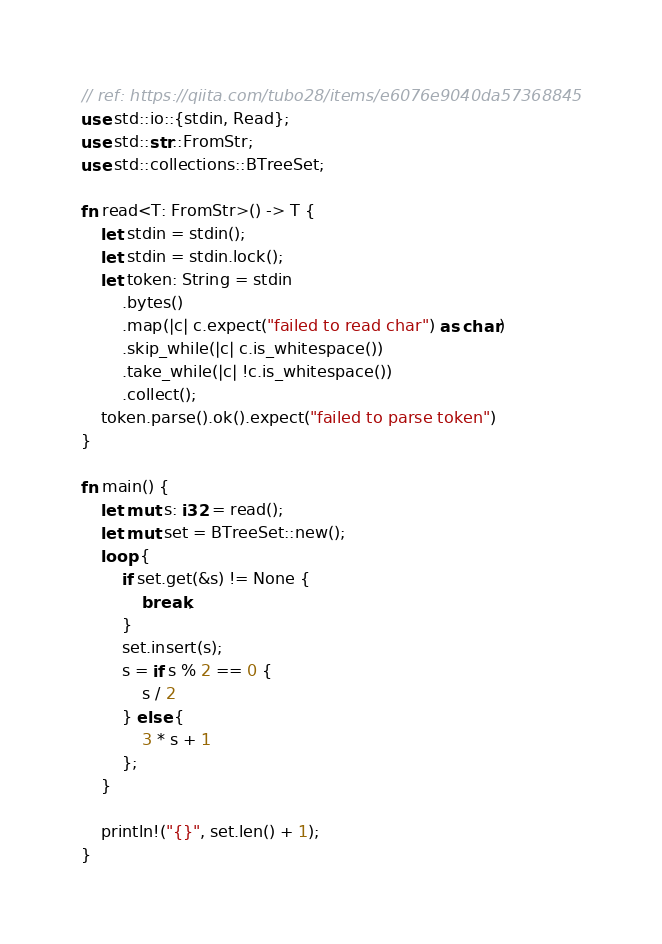Convert code to text. <code><loc_0><loc_0><loc_500><loc_500><_Rust_>// ref: https://qiita.com/tubo28/items/e6076e9040da57368845
use std::io::{stdin, Read};
use std::str::FromStr;
use std::collections::BTreeSet;

fn read<T: FromStr>() -> T {
    let stdin = stdin();
    let stdin = stdin.lock();
    let token: String = stdin
        .bytes()
        .map(|c| c.expect("failed to read char") as char)
        .skip_while(|c| c.is_whitespace())
        .take_while(|c| !c.is_whitespace())
        .collect();
    token.parse().ok().expect("failed to parse token")
}

fn main() {
    let mut s: i32 = read();
    let mut set = BTreeSet::new();
    loop {
        if set.get(&s) != None {
            break;
        }
        set.insert(s);
        s = if s % 2 == 0 {
            s / 2
        } else {
            3 * s + 1
        };
    }

    println!("{}", set.len() + 1);
}</code> 